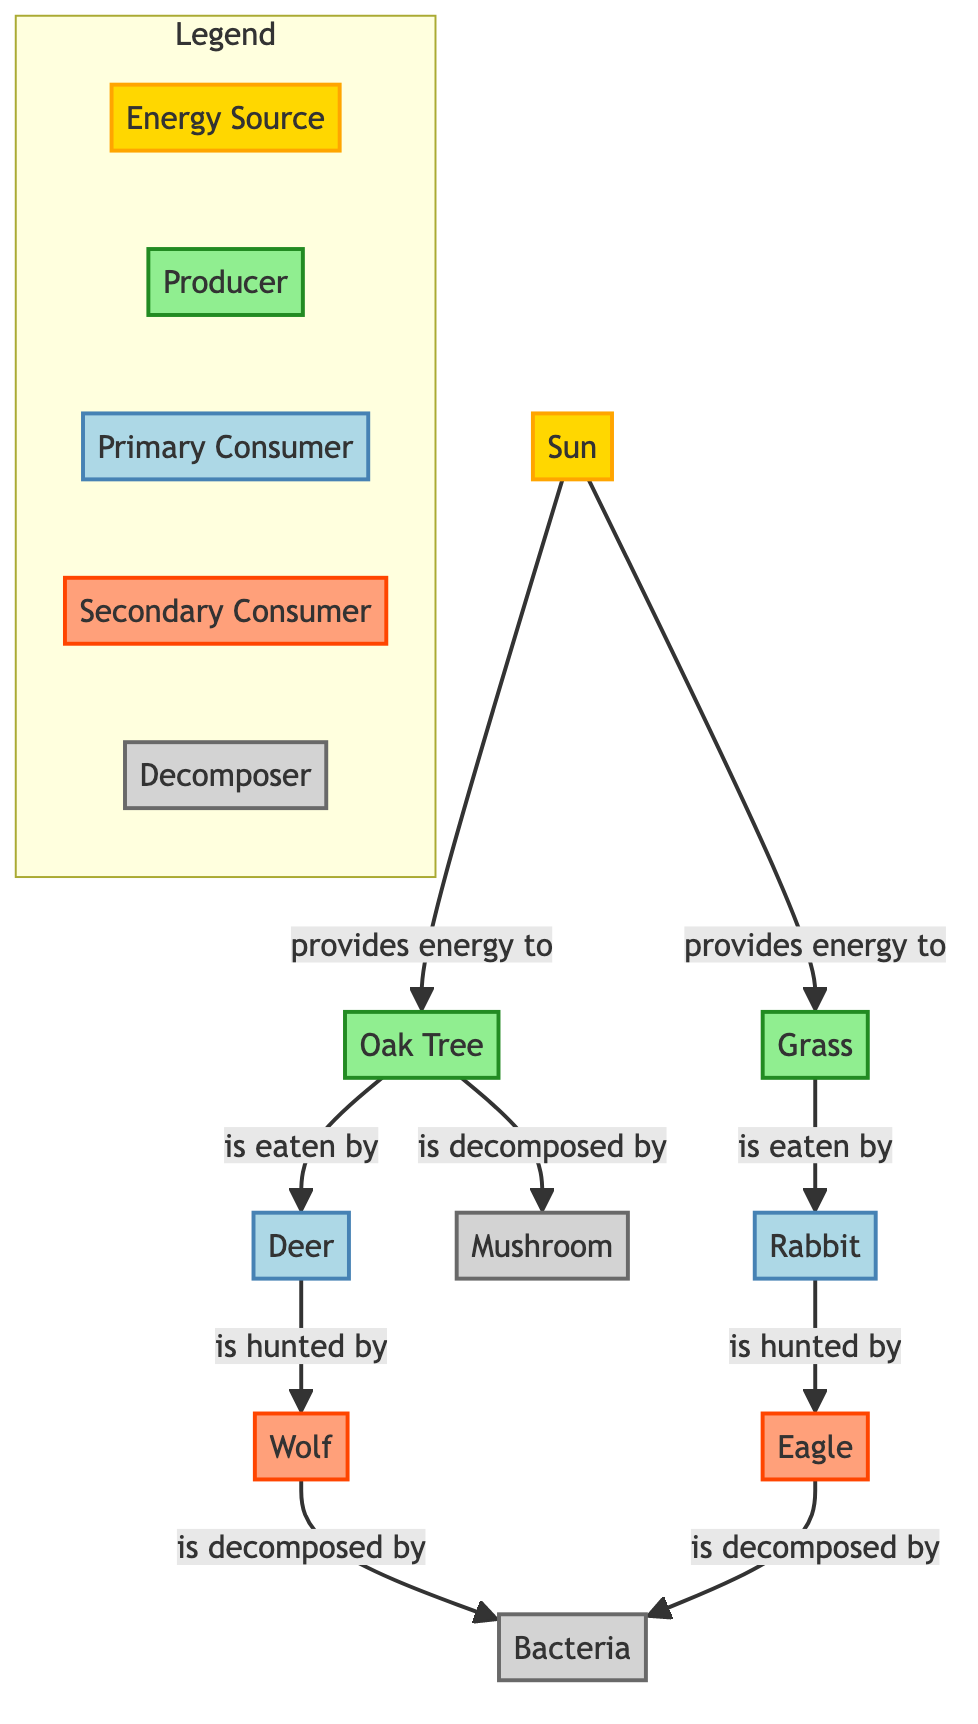What is the primary energy source in this ecosystem? The diagram indicates that the Sun is the primary energy source, providing energy to the producers, Oak Tree and Grass. Thus, following the flow from the Sun, it's clear that it provides energy to the first trophic level.
Answer: Sun How many primary consumers are in the food web? The primary consumers in the diagram are Deer and Rabbit. By counting the nodes classified as primary consumers, we see there are two distinct animals contributing to this level of the food web.
Answer: 2 What are the two organisms that are decomposed by bacteria? The diagram shows that both the Wolf and the Eagle are decomposed by Bacteria. By tracing the arrows leading to the decomposer category in the diagram, the answer is derived directly.
Answer: Wolf, Eagle Which producer is eaten by the primary consumer deer? Oak Tree is the producer that is specifically indicated to be eaten by the Deer in the diagram. Tracing the connections from the Oak Tree node, this relationship is clearly defined.
Answer: Oak Tree What type of consumer is a Rabbit? According to the diagram, the Rabbit is classified as a primary consumer. It is shown eating Grass, placing it firmly in this consumer category within the trophic structure.
Answer: Primary Consumer How many different types of consumers are represented in the diagram? The diagram shows three types of consumers: Primary Consumers (Deer, Rabbit), Secondary Consumers (Wolf, Eagle), totaling five consumers across these two categories. Adding them together gives us the total count of consumer types present.
Answer: 2 Who decomposes the Oak Tree? The decomposition of the Oak Tree is specifically attributed to the Mushroom in the diagram. Following the flow from the Oak Tree to its corresponding decomposer node shows this relationship clearly.
Answer: Mushroom Which organism is a secondary consumer that hunts the Rabbit? The Eagle is indicated as the secondary consumer that hunts the Rabbit in the food web. The diagram shows a direct arrow from Rabbit to Eagle, signifying this hunting relationship in the ecosystem.
Answer: Eagle 